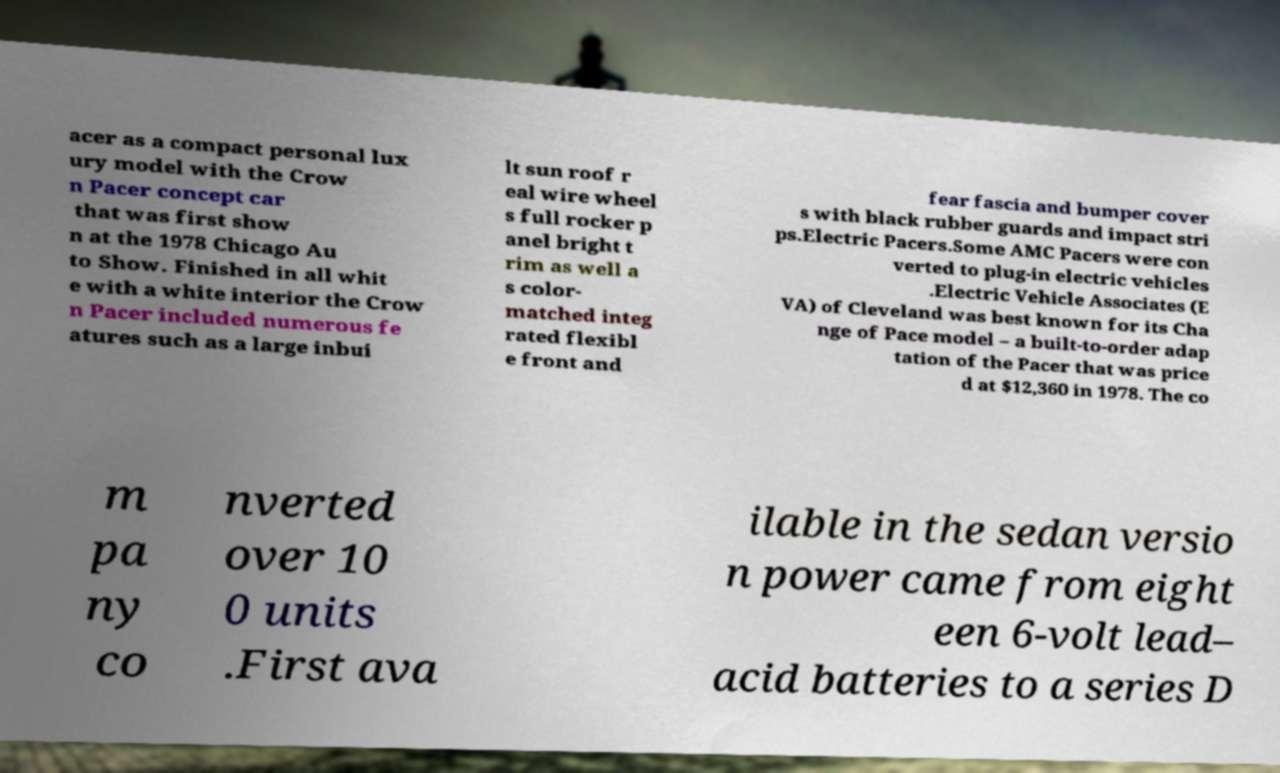Please read and relay the text visible in this image. What does it say? acer as a compact personal lux ury model with the Crow n Pacer concept car that was first show n at the 1978 Chicago Au to Show. Finished in all whit e with a white interior the Crow n Pacer included numerous fe atures such as a large inbui lt sun roof r eal wire wheel s full rocker p anel bright t rim as well a s color- matched integ rated flexibl e front and fear fascia and bumper cover s with black rubber guards and impact stri ps.Electric Pacers.Some AMC Pacers were con verted to plug-in electric vehicles .Electric Vehicle Associates (E VA) of Cleveland was best known for its Cha nge of Pace model – a built-to-order adap tation of the Pacer that was price d at $12,360 in 1978. The co m pa ny co nverted over 10 0 units .First ava ilable in the sedan versio n power came from eight een 6-volt lead– acid batteries to a series D 